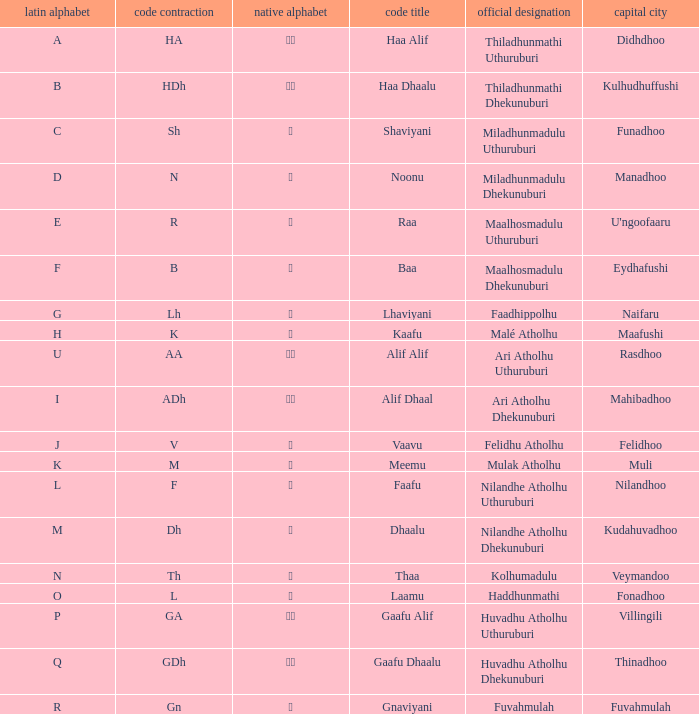The capital of funadhoo has what local letter? ށ. 